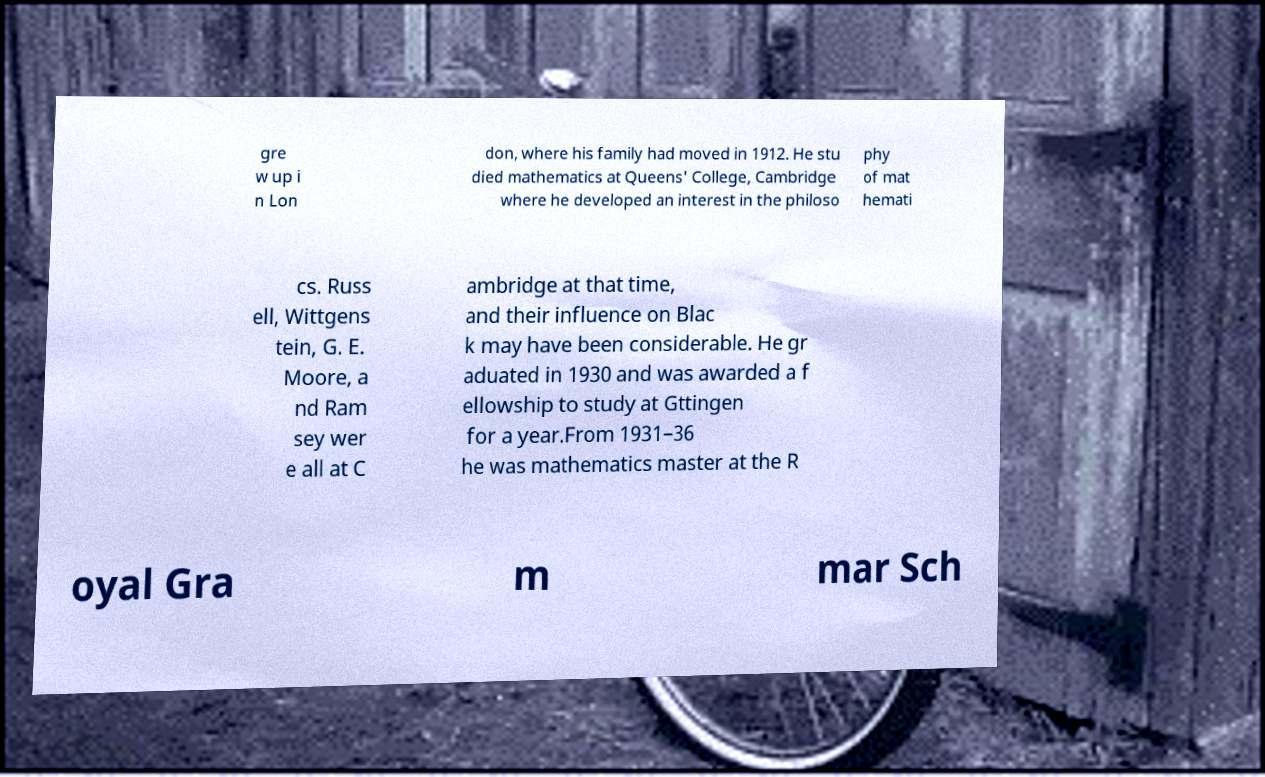Can you accurately transcribe the text from the provided image for me? gre w up i n Lon don, where his family had moved in 1912. He stu died mathematics at Queens' College, Cambridge where he developed an interest in the philoso phy of mat hemati cs. Russ ell, Wittgens tein, G. E. Moore, a nd Ram sey wer e all at C ambridge at that time, and their influence on Blac k may have been considerable. He gr aduated in 1930 and was awarded a f ellowship to study at Gttingen for a year.From 1931–36 he was mathematics master at the R oyal Gra m mar Sch 